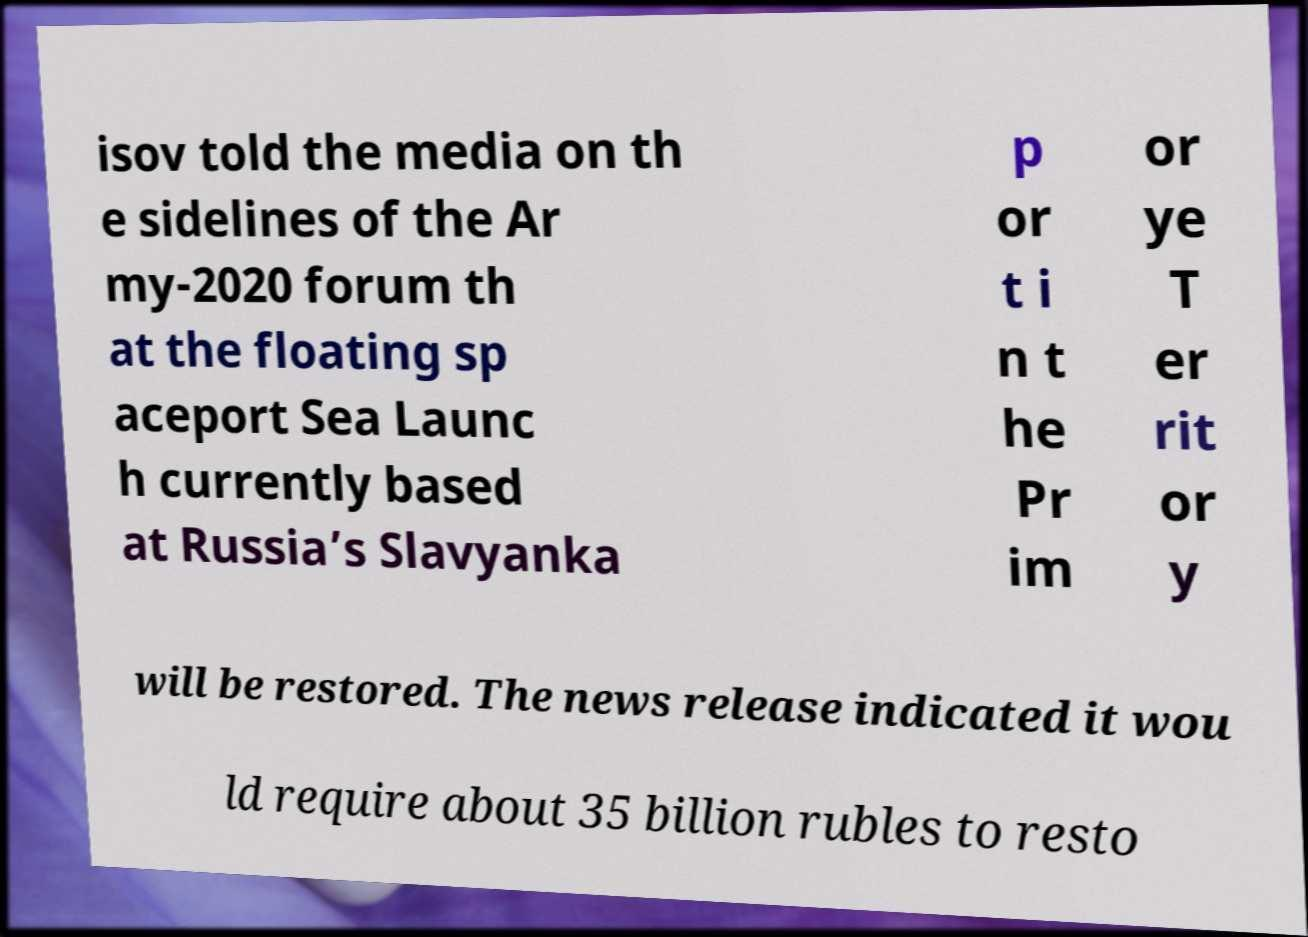I need the written content from this picture converted into text. Can you do that? isov told the media on th e sidelines of the Ar my-2020 forum th at the floating sp aceport Sea Launc h currently based at Russia’s Slavyanka p or t i n t he Pr im or ye T er rit or y will be restored. The news release indicated it wou ld require about 35 billion rubles to resto 